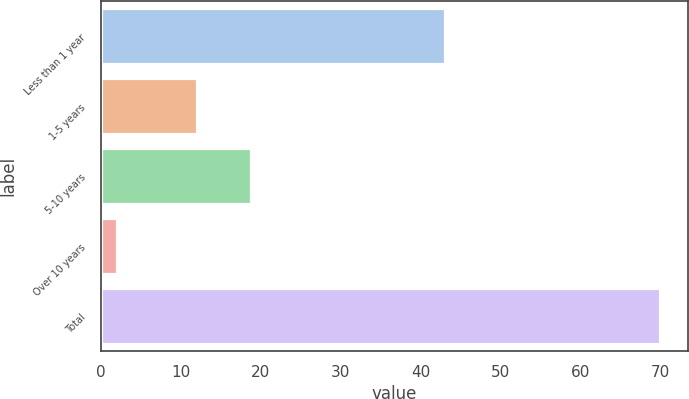Convert chart. <chart><loc_0><loc_0><loc_500><loc_500><bar_chart><fcel>Less than 1 year<fcel>1-5 years<fcel>5-10 years<fcel>Over 10 years<fcel>Total<nl><fcel>43<fcel>12<fcel>18.8<fcel>2<fcel>70<nl></chart> 